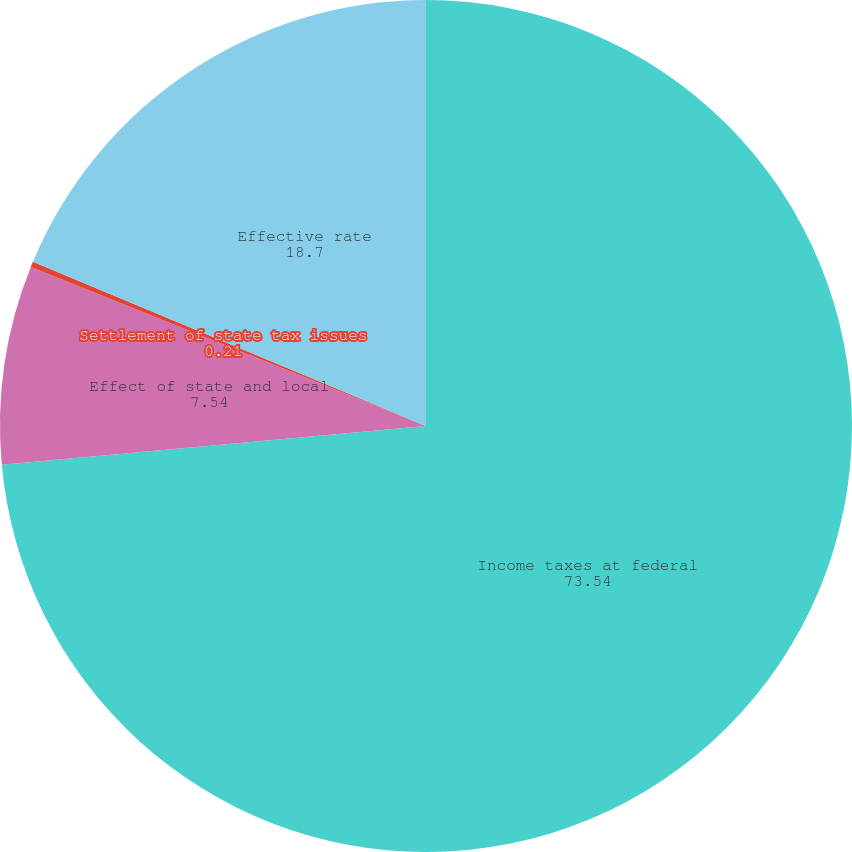<chart> <loc_0><loc_0><loc_500><loc_500><pie_chart><fcel>Income taxes at federal<fcel>Effect of state and local<fcel>Settlement of state tax issues<fcel>Effective rate<nl><fcel>73.54%<fcel>7.54%<fcel>0.21%<fcel>18.7%<nl></chart> 